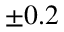<formula> <loc_0><loc_0><loc_500><loc_500>\pm 0 . 2</formula> 